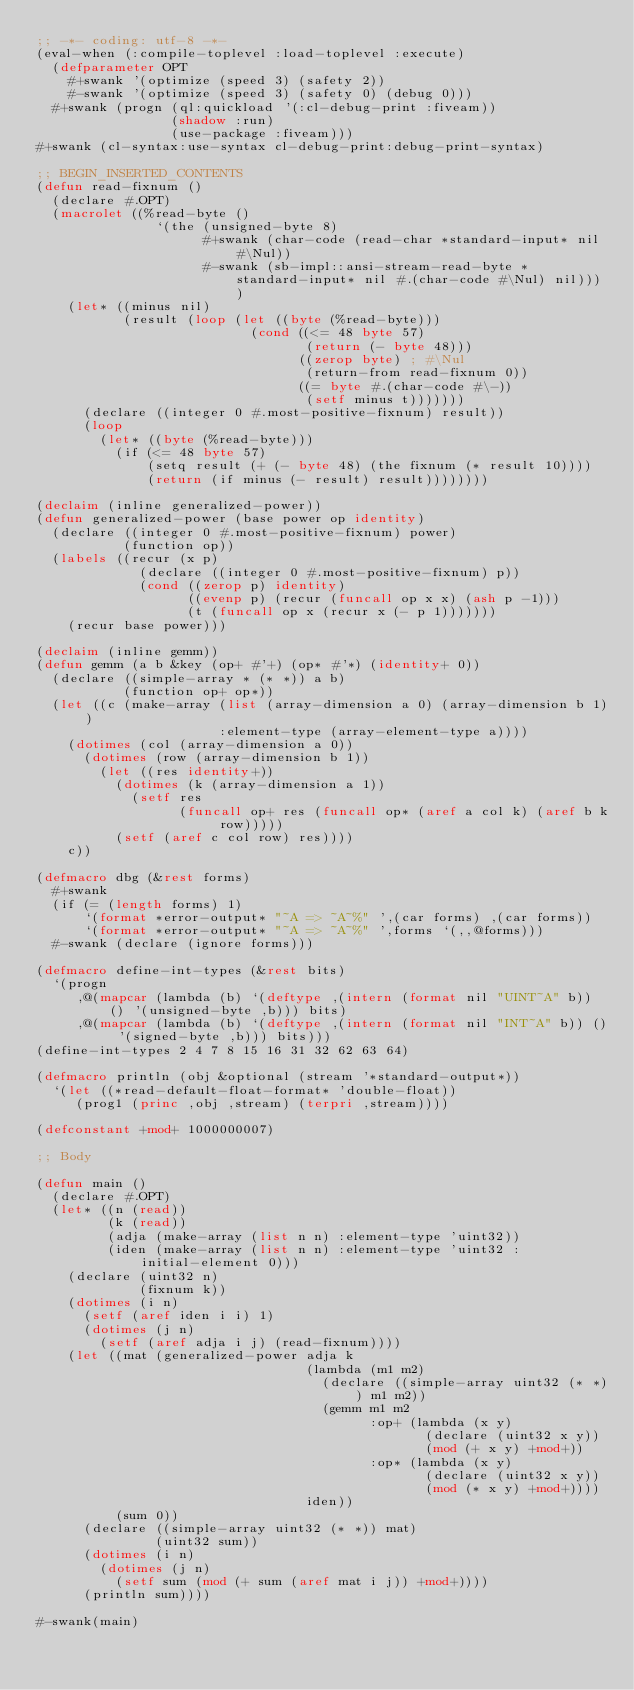Convert code to text. <code><loc_0><loc_0><loc_500><loc_500><_Lisp_>;; -*- coding: utf-8 -*-
(eval-when (:compile-toplevel :load-toplevel :execute)
  (defparameter OPT
    #+swank '(optimize (speed 3) (safety 2))
    #-swank '(optimize (speed 3) (safety 0) (debug 0)))
  #+swank (progn (ql:quickload '(:cl-debug-print :fiveam))
                 (shadow :run)
                 (use-package :fiveam)))
#+swank (cl-syntax:use-syntax cl-debug-print:debug-print-syntax)

;; BEGIN_INSERTED_CONTENTS
(defun read-fixnum ()
  (declare #.OPT)
  (macrolet ((%read-byte ()
               `(the (unsigned-byte 8)
                     #+swank (char-code (read-char *standard-input* nil #\Nul))
                     #-swank (sb-impl::ansi-stream-read-byte *standard-input* nil #.(char-code #\Nul) nil))))
    (let* ((minus nil)
           (result (loop (let ((byte (%read-byte)))
                           (cond ((<= 48 byte 57)
                                  (return (- byte 48)))
                                 ((zerop byte) ; #\Nul
                                  (return-from read-fixnum 0))
                                 ((= byte #.(char-code #\-))
                                  (setf minus t)))))))
      (declare ((integer 0 #.most-positive-fixnum) result))
      (loop
        (let* ((byte (%read-byte)))
          (if (<= 48 byte 57)
              (setq result (+ (- byte 48) (the fixnum (* result 10))))
              (return (if minus (- result) result))))))))

(declaim (inline generalized-power))
(defun generalized-power (base power op identity)
  (declare ((integer 0 #.most-positive-fixnum) power)
           (function op))
  (labels ((recur (x p)
             (declare ((integer 0 #.most-positive-fixnum) p))
             (cond ((zerop p) identity)
                   ((evenp p) (recur (funcall op x x) (ash p -1)))
                   (t (funcall op x (recur x (- p 1)))))))
    (recur base power)))

(declaim (inline gemm))
(defun gemm (a b &key (op+ #'+) (op* #'*) (identity+ 0))
  (declare ((simple-array * (* *)) a b)
           (function op+ op*))
  (let ((c (make-array (list (array-dimension a 0) (array-dimension b 1))
                       :element-type (array-element-type a))))
    (dotimes (col (array-dimension a 0))
      (dotimes (row (array-dimension b 1))
        (let ((res identity+))
          (dotimes (k (array-dimension a 1))
            (setf res
                  (funcall op+ res (funcall op* (aref a col k) (aref b k row)))))
          (setf (aref c col row) res))))
    c))

(defmacro dbg (&rest forms)
  #+swank
  (if (= (length forms) 1)
      `(format *error-output* "~A => ~A~%" ',(car forms) ,(car forms))
      `(format *error-output* "~A => ~A~%" ',forms `(,,@forms)))
  #-swank (declare (ignore forms)))

(defmacro define-int-types (&rest bits)
  `(progn
     ,@(mapcar (lambda (b) `(deftype ,(intern (format nil "UINT~A" b)) () '(unsigned-byte ,b))) bits)
     ,@(mapcar (lambda (b) `(deftype ,(intern (format nil "INT~A" b)) () '(signed-byte ,b))) bits)))
(define-int-types 2 4 7 8 15 16 31 32 62 63 64)

(defmacro println (obj &optional (stream '*standard-output*))
  `(let ((*read-default-float-format* 'double-float))
     (prog1 (princ ,obj ,stream) (terpri ,stream))))

(defconstant +mod+ 1000000007)

;; Body

(defun main ()
  (declare #.OPT)
  (let* ((n (read))
         (k (read))
         (adja (make-array (list n n) :element-type 'uint32))
         (iden (make-array (list n n) :element-type 'uint32 :initial-element 0)))
    (declare (uint32 n)
             (fixnum k))
    (dotimes (i n)
      (setf (aref iden i i) 1)
      (dotimes (j n)
        (setf (aref adja i j) (read-fixnum))))
    (let ((mat (generalized-power adja k
                                  (lambda (m1 m2)
                                    (declare ((simple-array uint32 (* *)) m1 m2))
                                    (gemm m1 m2
                                          :op+ (lambda (x y)
                                                 (declare (uint32 x y))
                                                 (mod (+ x y) +mod+))
                                          :op* (lambda (x y)
                                                 (declare (uint32 x y))
                                                 (mod (* x y) +mod+))))
                                  iden))
          (sum 0))
      (declare ((simple-array uint32 (* *)) mat)
               (uint32 sum))
      (dotimes (i n)
        (dotimes (j n)
          (setf sum (mod (+ sum (aref mat i j)) +mod+))))
      (println sum))))

#-swank(main)
</code> 